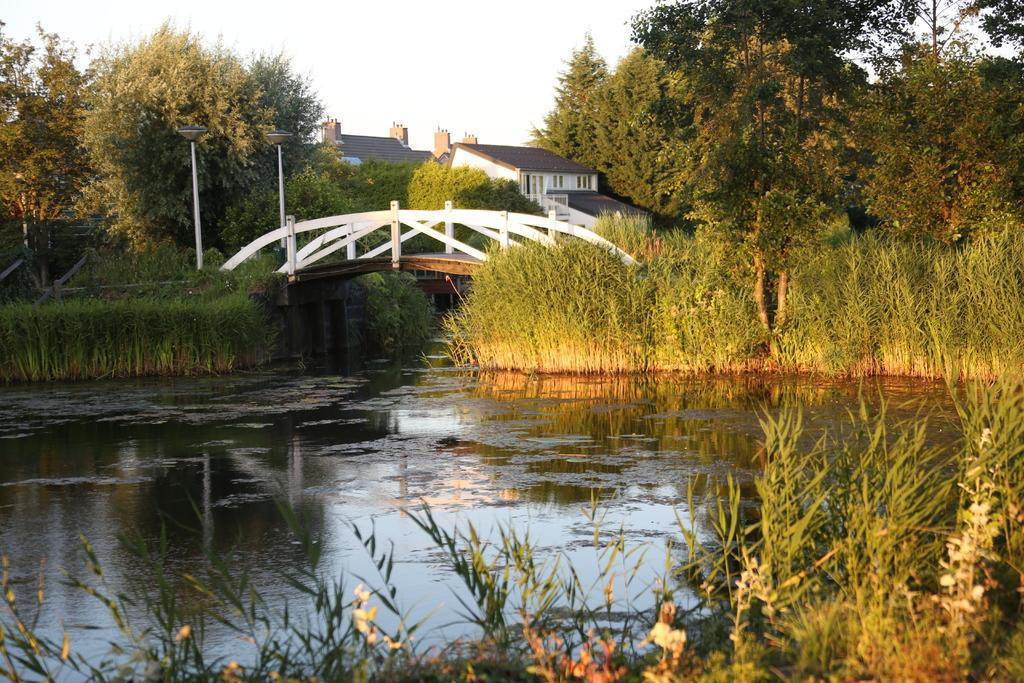Describe this image in one or two sentences. In this image I can see water and I can see a bridge over the water. I can also see bushes in the front and in the background. I can also see number of trees, two buildings and the sky in the background. 